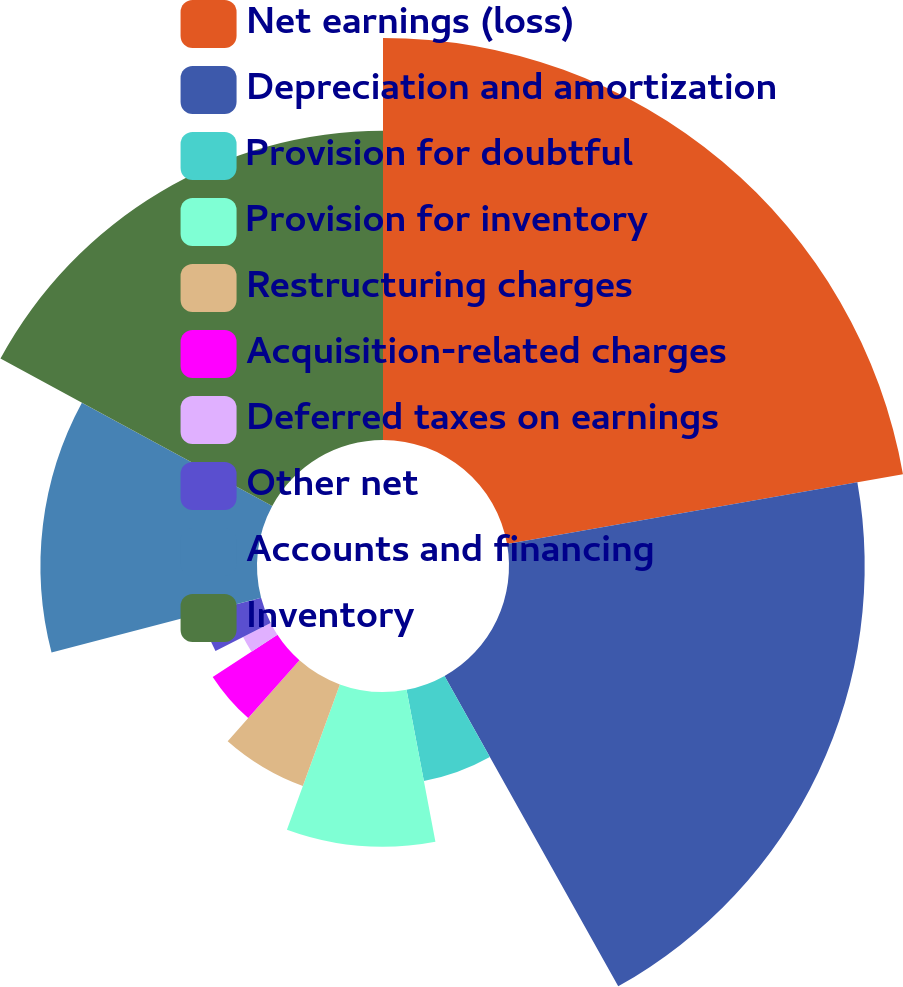<chart> <loc_0><loc_0><loc_500><loc_500><pie_chart><fcel>Net earnings (loss)<fcel>Depreciation and amortization<fcel>Provision for doubtful<fcel>Provision for inventory<fcel>Restructuring charges<fcel>Acquisition-related charges<fcel>Deferred taxes on earnings<fcel>Other net<fcel>Accounts and financing<fcel>Inventory<nl><fcel>22.22%<fcel>19.66%<fcel>5.13%<fcel>8.55%<fcel>5.98%<fcel>4.27%<fcel>1.71%<fcel>3.42%<fcel>11.97%<fcel>17.09%<nl></chart> 